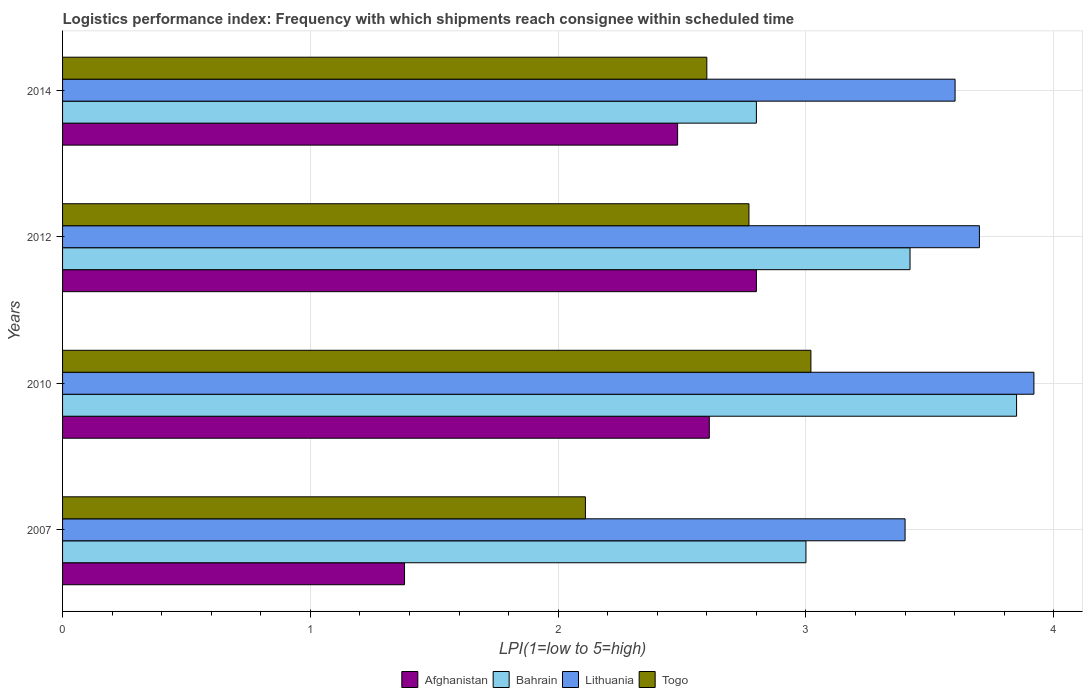How many groups of bars are there?
Your answer should be compact. 4. Are the number of bars on each tick of the Y-axis equal?
Make the answer very short. Yes. In how many cases, is the number of bars for a given year not equal to the number of legend labels?
Offer a terse response. 0. Across all years, what is the maximum logistics performance index in Bahrain?
Provide a short and direct response. 3.85. Across all years, what is the minimum logistics performance index in Afghanistan?
Provide a succinct answer. 1.38. In which year was the logistics performance index in Togo minimum?
Give a very brief answer. 2007. What is the total logistics performance index in Togo in the graph?
Offer a very short reply. 10.5. What is the difference between the logistics performance index in Togo in 2010 and that in 2012?
Make the answer very short. 0.25. What is the difference between the logistics performance index in Lithuania in 2010 and the logistics performance index in Afghanistan in 2007?
Your answer should be compact. 2.54. What is the average logistics performance index in Lithuania per year?
Give a very brief answer. 3.66. In the year 2007, what is the difference between the logistics performance index in Bahrain and logistics performance index in Lithuania?
Your answer should be very brief. -0.4. What is the ratio of the logistics performance index in Lithuania in 2012 to that in 2014?
Give a very brief answer. 1.03. Is the logistics performance index in Bahrain in 2010 less than that in 2014?
Offer a very short reply. No. Is the difference between the logistics performance index in Bahrain in 2007 and 2014 greater than the difference between the logistics performance index in Lithuania in 2007 and 2014?
Offer a very short reply. Yes. What is the difference between the highest and the second highest logistics performance index in Togo?
Offer a terse response. 0.25. What is the difference between the highest and the lowest logistics performance index in Togo?
Give a very brief answer. 0.91. Is the sum of the logistics performance index in Bahrain in 2012 and 2014 greater than the maximum logistics performance index in Togo across all years?
Keep it short and to the point. Yes. Is it the case that in every year, the sum of the logistics performance index in Lithuania and logistics performance index in Bahrain is greater than the sum of logistics performance index in Afghanistan and logistics performance index in Togo?
Ensure brevity in your answer.  No. What does the 4th bar from the top in 2014 represents?
Your response must be concise. Afghanistan. What does the 2nd bar from the bottom in 2010 represents?
Provide a short and direct response. Bahrain. Is it the case that in every year, the sum of the logistics performance index in Bahrain and logistics performance index in Togo is greater than the logistics performance index in Afghanistan?
Offer a terse response. Yes. How many bars are there?
Make the answer very short. 16. Are all the bars in the graph horizontal?
Your answer should be very brief. Yes. What is the difference between two consecutive major ticks on the X-axis?
Keep it short and to the point. 1. Does the graph contain any zero values?
Make the answer very short. No. How many legend labels are there?
Your answer should be compact. 4. What is the title of the graph?
Provide a succinct answer. Logistics performance index: Frequency with which shipments reach consignee within scheduled time. What is the label or title of the X-axis?
Your response must be concise. LPI(1=low to 5=high). What is the LPI(1=low to 5=high) of Afghanistan in 2007?
Keep it short and to the point. 1.38. What is the LPI(1=low to 5=high) in Bahrain in 2007?
Offer a terse response. 3. What is the LPI(1=low to 5=high) of Lithuania in 2007?
Your answer should be compact. 3.4. What is the LPI(1=low to 5=high) in Togo in 2007?
Provide a short and direct response. 2.11. What is the LPI(1=low to 5=high) in Afghanistan in 2010?
Make the answer very short. 2.61. What is the LPI(1=low to 5=high) in Bahrain in 2010?
Make the answer very short. 3.85. What is the LPI(1=low to 5=high) of Lithuania in 2010?
Your answer should be compact. 3.92. What is the LPI(1=low to 5=high) of Togo in 2010?
Provide a short and direct response. 3.02. What is the LPI(1=low to 5=high) of Afghanistan in 2012?
Provide a short and direct response. 2.8. What is the LPI(1=low to 5=high) of Bahrain in 2012?
Give a very brief answer. 3.42. What is the LPI(1=low to 5=high) in Togo in 2012?
Your answer should be very brief. 2.77. What is the LPI(1=low to 5=high) in Afghanistan in 2014?
Give a very brief answer. 2.48. What is the LPI(1=low to 5=high) of Lithuania in 2014?
Provide a short and direct response. 3.6. What is the LPI(1=low to 5=high) of Togo in 2014?
Offer a very short reply. 2.6. Across all years, what is the maximum LPI(1=low to 5=high) in Afghanistan?
Keep it short and to the point. 2.8. Across all years, what is the maximum LPI(1=low to 5=high) of Bahrain?
Keep it short and to the point. 3.85. Across all years, what is the maximum LPI(1=low to 5=high) in Lithuania?
Give a very brief answer. 3.92. Across all years, what is the maximum LPI(1=low to 5=high) of Togo?
Offer a terse response. 3.02. Across all years, what is the minimum LPI(1=low to 5=high) of Afghanistan?
Your response must be concise. 1.38. Across all years, what is the minimum LPI(1=low to 5=high) of Togo?
Make the answer very short. 2.11. What is the total LPI(1=low to 5=high) of Afghanistan in the graph?
Offer a terse response. 9.27. What is the total LPI(1=low to 5=high) in Bahrain in the graph?
Your answer should be compact. 13.07. What is the total LPI(1=low to 5=high) of Lithuania in the graph?
Ensure brevity in your answer.  14.62. What is the difference between the LPI(1=low to 5=high) in Afghanistan in 2007 and that in 2010?
Offer a terse response. -1.23. What is the difference between the LPI(1=low to 5=high) of Bahrain in 2007 and that in 2010?
Give a very brief answer. -0.85. What is the difference between the LPI(1=low to 5=high) of Lithuania in 2007 and that in 2010?
Give a very brief answer. -0.52. What is the difference between the LPI(1=low to 5=high) of Togo in 2007 and that in 2010?
Provide a short and direct response. -0.91. What is the difference between the LPI(1=low to 5=high) in Afghanistan in 2007 and that in 2012?
Your answer should be very brief. -1.42. What is the difference between the LPI(1=low to 5=high) of Bahrain in 2007 and that in 2012?
Make the answer very short. -0.42. What is the difference between the LPI(1=low to 5=high) of Lithuania in 2007 and that in 2012?
Your response must be concise. -0.3. What is the difference between the LPI(1=low to 5=high) of Togo in 2007 and that in 2012?
Offer a very short reply. -0.66. What is the difference between the LPI(1=low to 5=high) of Afghanistan in 2007 and that in 2014?
Provide a short and direct response. -1.1. What is the difference between the LPI(1=low to 5=high) in Lithuania in 2007 and that in 2014?
Ensure brevity in your answer.  -0.2. What is the difference between the LPI(1=low to 5=high) of Togo in 2007 and that in 2014?
Provide a succinct answer. -0.49. What is the difference between the LPI(1=low to 5=high) of Afghanistan in 2010 and that in 2012?
Your answer should be very brief. -0.19. What is the difference between the LPI(1=low to 5=high) of Bahrain in 2010 and that in 2012?
Your answer should be very brief. 0.43. What is the difference between the LPI(1=low to 5=high) in Lithuania in 2010 and that in 2012?
Offer a terse response. 0.22. What is the difference between the LPI(1=low to 5=high) in Afghanistan in 2010 and that in 2014?
Your answer should be compact. 0.13. What is the difference between the LPI(1=low to 5=high) of Bahrain in 2010 and that in 2014?
Your response must be concise. 1.05. What is the difference between the LPI(1=low to 5=high) of Lithuania in 2010 and that in 2014?
Keep it short and to the point. 0.32. What is the difference between the LPI(1=low to 5=high) in Togo in 2010 and that in 2014?
Make the answer very short. 0.42. What is the difference between the LPI(1=low to 5=high) in Afghanistan in 2012 and that in 2014?
Your answer should be compact. 0.32. What is the difference between the LPI(1=low to 5=high) of Bahrain in 2012 and that in 2014?
Your answer should be compact. 0.62. What is the difference between the LPI(1=low to 5=high) of Lithuania in 2012 and that in 2014?
Provide a short and direct response. 0.1. What is the difference between the LPI(1=low to 5=high) in Togo in 2012 and that in 2014?
Your answer should be very brief. 0.17. What is the difference between the LPI(1=low to 5=high) in Afghanistan in 2007 and the LPI(1=low to 5=high) in Bahrain in 2010?
Keep it short and to the point. -2.47. What is the difference between the LPI(1=low to 5=high) in Afghanistan in 2007 and the LPI(1=low to 5=high) in Lithuania in 2010?
Make the answer very short. -2.54. What is the difference between the LPI(1=low to 5=high) of Afghanistan in 2007 and the LPI(1=low to 5=high) of Togo in 2010?
Offer a very short reply. -1.64. What is the difference between the LPI(1=low to 5=high) in Bahrain in 2007 and the LPI(1=low to 5=high) in Lithuania in 2010?
Offer a very short reply. -0.92. What is the difference between the LPI(1=low to 5=high) of Bahrain in 2007 and the LPI(1=low to 5=high) of Togo in 2010?
Make the answer very short. -0.02. What is the difference between the LPI(1=low to 5=high) of Lithuania in 2007 and the LPI(1=low to 5=high) of Togo in 2010?
Keep it short and to the point. 0.38. What is the difference between the LPI(1=low to 5=high) in Afghanistan in 2007 and the LPI(1=low to 5=high) in Bahrain in 2012?
Your answer should be very brief. -2.04. What is the difference between the LPI(1=low to 5=high) in Afghanistan in 2007 and the LPI(1=low to 5=high) in Lithuania in 2012?
Offer a very short reply. -2.32. What is the difference between the LPI(1=low to 5=high) of Afghanistan in 2007 and the LPI(1=low to 5=high) of Togo in 2012?
Keep it short and to the point. -1.39. What is the difference between the LPI(1=low to 5=high) of Bahrain in 2007 and the LPI(1=low to 5=high) of Togo in 2012?
Ensure brevity in your answer.  0.23. What is the difference between the LPI(1=low to 5=high) in Lithuania in 2007 and the LPI(1=low to 5=high) in Togo in 2012?
Give a very brief answer. 0.63. What is the difference between the LPI(1=low to 5=high) of Afghanistan in 2007 and the LPI(1=low to 5=high) of Bahrain in 2014?
Offer a very short reply. -1.42. What is the difference between the LPI(1=low to 5=high) of Afghanistan in 2007 and the LPI(1=low to 5=high) of Lithuania in 2014?
Your response must be concise. -2.22. What is the difference between the LPI(1=low to 5=high) in Afghanistan in 2007 and the LPI(1=low to 5=high) in Togo in 2014?
Your answer should be compact. -1.22. What is the difference between the LPI(1=low to 5=high) in Bahrain in 2007 and the LPI(1=low to 5=high) in Lithuania in 2014?
Ensure brevity in your answer.  -0.6. What is the difference between the LPI(1=low to 5=high) of Lithuania in 2007 and the LPI(1=low to 5=high) of Togo in 2014?
Your response must be concise. 0.8. What is the difference between the LPI(1=low to 5=high) in Afghanistan in 2010 and the LPI(1=low to 5=high) in Bahrain in 2012?
Provide a succinct answer. -0.81. What is the difference between the LPI(1=low to 5=high) of Afghanistan in 2010 and the LPI(1=low to 5=high) of Lithuania in 2012?
Provide a short and direct response. -1.09. What is the difference between the LPI(1=low to 5=high) in Afghanistan in 2010 and the LPI(1=low to 5=high) in Togo in 2012?
Offer a very short reply. -0.16. What is the difference between the LPI(1=low to 5=high) of Bahrain in 2010 and the LPI(1=low to 5=high) of Lithuania in 2012?
Offer a very short reply. 0.15. What is the difference between the LPI(1=low to 5=high) in Bahrain in 2010 and the LPI(1=low to 5=high) in Togo in 2012?
Ensure brevity in your answer.  1.08. What is the difference between the LPI(1=low to 5=high) in Lithuania in 2010 and the LPI(1=low to 5=high) in Togo in 2012?
Offer a very short reply. 1.15. What is the difference between the LPI(1=low to 5=high) of Afghanistan in 2010 and the LPI(1=low to 5=high) of Bahrain in 2014?
Keep it short and to the point. -0.19. What is the difference between the LPI(1=low to 5=high) in Afghanistan in 2010 and the LPI(1=low to 5=high) in Lithuania in 2014?
Your answer should be compact. -0.99. What is the difference between the LPI(1=low to 5=high) in Bahrain in 2010 and the LPI(1=low to 5=high) in Lithuania in 2014?
Ensure brevity in your answer.  0.25. What is the difference between the LPI(1=low to 5=high) of Bahrain in 2010 and the LPI(1=low to 5=high) of Togo in 2014?
Offer a very short reply. 1.25. What is the difference between the LPI(1=low to 5=high) of Lithuania in 2010 and the LPI(1=low to 5=high) of Togo in 2014?
Give a very brief answer. 1.32. What is the difference between the LPI(1=low to 5=high) of Afghanistan in 2012 and the LPI(1=low to 5=high) of Lithuania in 2014?
Give a very brief answer. -0.8. What is the difference between the LPI(1=low to 5=high) in Bahrain in 2012 and the LPI(1=low to 5=high) in Lithuania in 2014?
Ensure brevity in your answer.  -0.18. What is the difference between the LPI(1=low to 5=high) of Bahrain in 2012 and the LPI(1=low to 5=high) of Togo in 2014?
Your answer should be very brief. 0.82. What is the average LPI(1=low to 5=high) of Afghanistan per year?
Ensure brevity in your answer.  2.32. What is the average LPI(1=low to 5=high) in Bahrain per year?
Your answer should be compact. 3.27. What is the average LPI(1=low to 5=high) in Lithuania per year?
Make the answer very short. 3.66. What is the average LPI(1=low to 5=high) of Togo per year?
Offer a very short reply. 2.62. In the year 2007, what is the difference between the LPI(1=low to 5=high) of Afghanistan and LPI(1=low to 5=high) of Bahrain?
Make the answer very short. -1.62. In the year 2007, what is the difference between the LPI(1=low to 5=high) in Afghanistan and LPI(1=low to 5=high) in Lithuania?
Keep it short and to the point. -2.02. In the year 2007, what is the difference between the LPI(1=low to 5=high) in Afghanistan and LPI(1=low to 5=high) in Togo?
Make the answer very short. -0.73. In the year 2007, what is the difference between the LPI(1=low to 5=high) in Bahrain and LPI(1=low to 5=high) in Togo?
Your answer should be compact. 0.89. In the year 2007, what is the difference between the LPI(1=low to 5=high) of Lithuania and LPI(1=low to 5=high) of Togo?
Keep it short and to the point. 1.29. In the year 2010, what is the difference between the LPI(1=low to 5=high) of Afghanistan and LPI(1=low to 5=high) of Bahrain?
Offer a very short reply. -1.24. In the year 2010, what is the difference between the LPI(1=low to 5=high) in Afghanistan and LPI(1=low to 5=high) in Lithuania?
Provide a short and direct response. -1.31. In the year 2010, what is the difference between the LPI(1=low to 5=high) in Afghanistan and LPI(1=low to 5=high) in Togo?
Provide a succinct answer. -0.41. In the year 2010, what is the difference between the LPI(1=low to 5=high) in Bahrain and LPI(1=low to 5=high) in Lithuania?
Your answer should be very brief. -0.07. In the year 2010, what is the difference between the LPI(1=low to 5=high) in Bahrain and LPI(1=low to 5=high) in Togo?
Provide a short and direct response. 0.83. In the year 2010, what is the difference between the LPI(1=low to 5=high) of Lithuania and LPI(1=low to 5=high) of Togo?
Your answer should be very brief. 0.9. In the year 2012, what is the difference between the LPI(1=low to 5=high) of Afghanistan and LPI(1=low to 5=high) of Bahrain?
Keep it short and to the point. -0.62. In the year 2012, what is the difference between the LPI(1=low to 5=high) in Afghanistan and LPI(1=low to 5=high) in Togo?
Provide a succinct answer. 0.03. In the year 2012, what is the difference between the LPI(1=low to 5=high) in Bahrain and LPI(1=low to 5=high) in Lithuania?
Keep it short and to the point. -0.28. In the year 2012, what is the difference between the LPI(1=low to 5=high) of Bahrain and LPI(1=low to 5=high) of Togo?
Provide a succinct answer. 0.65. In the year 2012, what is the difference between the LPI(1=low to 5=high) of Lithuania and LPI(1=low to 5=high) of Togo?
Keep it short and to the point. 0.93. In the year 2014, what is the difference between the LPI(1=low to 5=high) in Afghanistan and LPI(1=low to 5=high) in Bahrain?
Make the answer very short. -0.32. In the year 2014, what is the difference between the LPI(1=low to 5=high) of Afghanistan and LPI(1=low to 5=high) of Lithuania?
Your answer should be compact. -1.12. In the year 2014, what is the difference between the LPI(1=low to 5=high) of Afghanistan and LPI(1=low to 5=high) of Togo?
Your answer should be compact. -0.12. In the year 2014, what is the difference between the LPI(1=low to 5=high) of Bahrain and LPI(1=low to 5=high) of Lithuania?
Offer a terse response. -0.8. In the year 2014, what is the difference between the LPI(1=low to 5=high) of Lithuania and LPI(1=low to 5=high) of Togo?
Provide a succinct answer. 1. What is the ratio of the LPI(1=low to 5=high) in Afghanistan in 2007 to that in 2010?
Provide a succinct answer. 0.53. What is the ratio of the LPI(1=low to 5=high) in Bahrain in 2007 to that in 2010?
Ensure brevity in your answer.  0.78. What is the ratio of the LPI(1=low to 5=high) of Lithuania in 2007 to that in 2010?
Your answer should be compact. 0.87. What is the ratio of the LPI(1=low to 5=high) in Togo in 2007 to that in 2010?
Make the answer very short. 0.7. What is the ratio of the LPI(1=low to 5=high) of Afghanistan in 2007 to that in 2012?
Provide a short and direct response. 0.49. What is the ratio of the LPI(1=low to 5=high) in Bahrain in 2007 to that in 2012?
Provide a succinct answer. 0.88. What is the ratio of the LPI(1=low to 5=high) in Lithuania in 2007 to that in 2012?
Keep it short and to the point. 0.92. What is the ratio of the LPI(1=low to 5=high) in Togo in 2007 to that in 2012?
Offer a very short reply. 0.76. What is the ratio of the LPI(1=low to 5=high) of Afghanistan in 2007 to that in 2014?
Your response must be concise. 0.56. What is the ratio of the LPI(1=low to 5=high) in Bahrain in 2007 to that in 2014?
Keep it short and to the point. 1.07. What is the ratio of the LPI(1=low to 5=high) of Lithuania in 2007 to that in 2014?
Your response must be concise. 0.94. What is the ratio of the LPI(1=low to 5=high) of Togo in 2007 to that in 2014?
Your answer should be very brief. 0.81. What is the ratio of the LPI(1=low to 5=high) of Afghanistan in 2010 to that in 2012?
Ensure brevity in your answer.  0.93. What is the ratio of the LPI(1=low to 5=high) of Bahrain in 2010 to that in 2012?
Your answer should be compact. 1.13. What is the ratio of the LPI(1=low to 5=high) in Lithuania in 2010 to that in 2012?
Offer a terse response. 1.06. What is the ratio of the LPI(1=low to 5=high) in Togo in 2010 to that in 2012?
Your answer should be very brief. 1.09. What is the ratio of the LPI(1=low to 5=high) in Afghanistan in 2010 to that in 2014?
Keep it short and to the point. 1.05. What is the ratio of the LPI(1=low to 5=high) of Bahrain in 2010 to that in 2014?
Offer a very short reply. 1.38. What is the ratio of the LPI(1=low to 5=high) in Lithuania in 2010 to that in 2014?
Provide a succinct answer. 1.09. What is the ratio of the LPI(1=low to 5=high) in Togo in 2010 to that in 2014?
Ensure brevity in your answer.  1.16. What is the ratio of the LPI(1=low to 5=high) of Afghanistan in 2012 to that in 2014?
Provide a short and direct response. 1.13. What is the ratio of the LPI(1=low to 5=high) of Bahrain in 2012 to that in 2014?
Give a very brief answer. 1.22. What is the ratio of the LPI(1=low to 5=high) of Lithuania in 2012 to that in 2014?
Your response must be concise. 1.03. What is the ratio of the LPI(1=low to 5=high) in Togo in 2012 to that in 2014?
Your response must be concise. 1.07. What is the difference between the highest and the second highest LPI(1=low to 5=high) of Afghanistan?
Your answer should be very brief. 0.19. What is the difference between the highest and the second highest LPI(1=low to 5=high) in Bahrain?
Make the answer very short. 0.43. What is the difference between the highest and the second highest LPI(1=low to 5=high) of Lithuania?
Give a very brief answer. 0.22. What is the difference between the highest and the second highest LPI(1=low to 5=high) of Togo?
Make the answer very short. 0.25. What is the difference between the highest and the lowest LPI(1=low to 5=high) of Afghanistan?
Your answer should be very brief. 1.42. What is the difference between the highest and the lowest LPI(1=low to 5=high) in Lithuania?
Keep it short and to the point. 0.52. What is the difference between the highest and the lowest LPI(1=low to 5=high) of Togo?
Your answer should be compact. 0.91. 